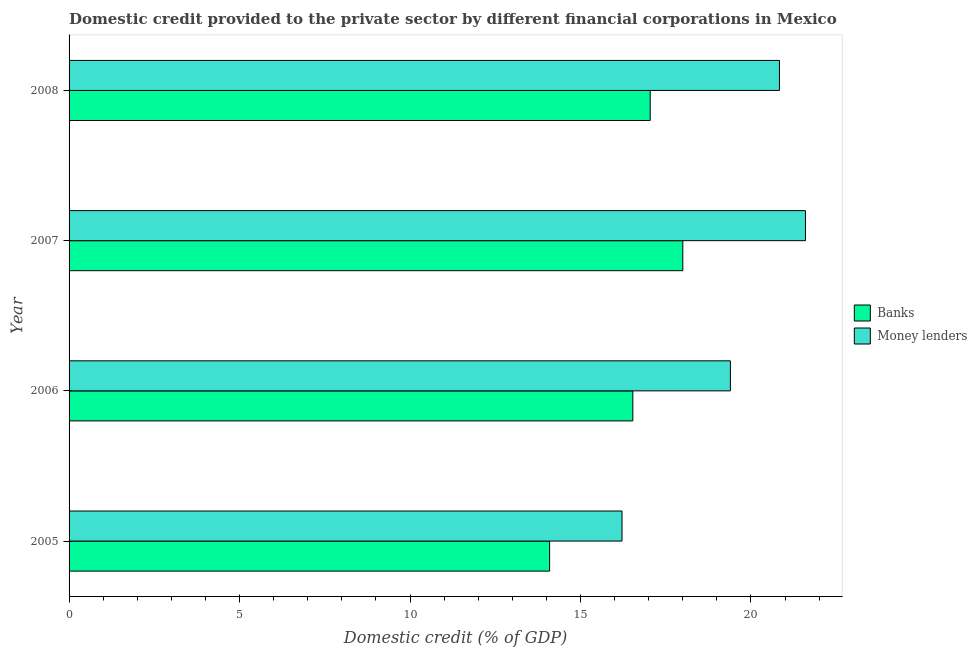How many groups of bars are there?
Your answer should be compact. 4. Are the number of bars on each tick of the Y-axis equal?
Provide a short and direct response. Yes. How many bars are there on the 3rd tick from the top?
Make the answer very short. 2. What is the label of the 3rd group of bars from the top?
Provide a succinct answer. 2006. What is the domestic credit provided by money lenders in 2005?
Keep it short and to the point. 16.22. Across all years, what is the maximum domestic credit provided by banks?
Ensure brevity in your answer.  18. Across all years, what is the minimum domestic credit provided by banks?
Your response must be concise. 14.1. In which year was the domestic credit provided by money lenders maximum?
Provide a short and direct response. 2007. In which year was the domestic credit provided by banks minimum?
Your response must be concise. 2005. What is the total domestic credit provided by money lenders in the graph?
Provide a succinct answer. 78.05. What is the difference between the domestic credit provided by banks in 2005 and that in 2006?
Ensure brevity in your answer.  -2.44. What is the difference between the domestic credit provided by banks in 2007 and the domestic credit provided by money lenders in 2006?
Offer a terse response. -1.4. What is the average domestic credit provided by banks per year?
Keep it short and to the point. 16.42. In the year 2007, what is the difference between the domestic credit provided by banks and domestic credit provided by money lenders?
Your answer should be very brief. -3.6. In how many years, is the domestic credit provided by banks greater than 14 %?
Give a very brief answer. 4. What is the ratio of the domestic credit provided by banks in 2007 to that in 2008?
Your answer should be compact. 1.06. Is the domestic credit provided by money lenders in 2006 less than that in 2007?
Your response must be concise. Yes. What is the difference between the highest and the second highest domestic credit provided by banks?
Offer a terse response. 0.96. What is the difference between the highest and the lowest domestic credit provided by banks?
Provide a succinct answer. 3.91. In how many years, is the domestic credit provided by banks greater than the average domestic credit provided by banks taken over all years?
Your response must be concise. 3. Is the sum of the domestic credit provided by banks in 2005 and 2008 greater than the maximum domestic credit provided by money lenders across all years?
Ensure brevity in your answer.  Yes. What does the 1st bar from the top in 2007 represents?
Provide a short and direct response. Money lenders. What does the 2nd bar from the bottom in 2006 represents?
Your answer should be very brief. Money lenders. How many bars are there?
Your answer should be compact. 8. Are all the bars in the graph horizontal?
Your response must be concise. Yes. What is the difference between two consecutive major ticks on the X-axis?
Keep it short and to the point. 5. Are the values on the major ticks of X-axis written in scientific E-notation?
Ensure brevity in your answer.  No. Does the graph contain any zero values?
Your answer should be compact. No. What is the title of the graph?
Make the answer very short. Domestic credit provided to the private sector by different financial corporations in Mexico. Does "Net savings(excluding particulate emission damage)" appear as one of the legend labels in the graph?
Ensure brevity in your answer.  No. What is the label or title of the X-axis?
Make the answer very short. Domestic credit (% of GDP). What is the label or title of the Y-axis?
Provide a short and direct response. Year. What is the Domestic credit (% of GDP) in Banks in 2005?
Provide a short and direct response. 14.1. What is the Domestic credit (% of GDP) in Money lenders in 2005?
Make the answer very short. 16.22. What is the Domestic credit (% of GDP) of Banks in 2006?
Your response must be concise. 16.54. What is the Domestic credit (% of GDP) in Money lenders in 2006?
Provide a short and direct response. 19.4. What is the Domestic credit (% of GDP) of Banks in 2007?
Make the answer very short. 18. What is the Domestic credit (% of GDP) of Money lenders in 2007?
Keep it short and to the point. 21.6. What is the Domestic credit (% of GDP) of Banks in 2008?
Offer a terse response. 17.05. What is the Domestic credit (% of GDP) of Money lenders in 2008?
Offer a terse response. 20.84. Across all years, what is the maximum Domestic credit (% of GDP) in Banks?
Your answer should be compact. 18. Across all years, what is the maximum Domestic credit (% of GDP) of Money lenders?
Offer a terse response. 21.6. Across all years, what is the minimum Domestic credit (% of GDP) of Banks?
Offer a very short reply. 14.1. Across all years, what is the minimum Domestic credit (% of GDP) in Money lenders?
Keep it short and to the point. 16.22. What is the total Domestic credit (% of GDP) of Banks in the graph?
Your response must be concise. 65.68. What is the total Domestic credit (% of GDP) of Money lenders in the graph?
Offer a terse response. 78.05. What is the difference between the Domestic credit (% of GDP) in Banks in 2005 and that in 2006?
Provide a short and direct response. -2.44. What is the difference between the Domestic credit (% of GDP) in Money lenders in 2005 and that in 2006?
Provide a succinct answer. -3.18. What is the difference between the Domestic credit (% of GDP) of Banks in 2005 and that in 2007?
Your answer should be very brief. -3.91. What is the difference between the Domestic credit (% of GDP) of Money lenders in 2005 and that in 2007?
Offer a very short reply. -5.38. What is the difference between the Domestic credit (% of GDP) of Banks in 2005 and that in 2008?
Your answer should be compact. -2.95. What is the difference between the Domestic credit (% of GDP) in Money lenders in 2005 and that in 2008?
Your response must be concise. -4.62. What is the difference between the Domestic credit (% of GDP) of Banks in 2006 and that in 2007?
Your answer should be compact. -1.47. What is the difference between the Domestic credit (% of GDP) in Money lenders in 2006 and that in 2007?
Offer a very short reply. -2.2. What is the difference between the Domestic credit (% of GDP) of Banks in 2006 and that in 2008?
Ensure brevity in your answer.  -0.51. What is the difference between the Domestic credit (% of GDP) in Money lenders in 2006 and that in 2008?
Your answer should be compact. -1.44. What is the difference between the Domestic credit (% of GDP) of Banks in 2007 and that in 2008?
Keep it short and to the point. 0.96. What is the difference between the Domestic credit (% of GDP) of Money lenders in 2007 and that in 2008?
Give a very brief answer. 0.76. What is the difference between the Domestic credit (% of GDP) in Banks in 2005 and the Domestic credit (% of GDP) in Money lenders in 2006?
Provide a succinct answer. -5.3. What is the difference between the Domestic credit (% of GDP) of Banks in 2005 and the Domestic credit (% of GDP) of Money lenders in 2007?
Offer a terse response. -7.5. What is the difference between the Domestic credit (% of GDP) in Banks in 2005 and the Domestic credit (% of GDP) in Money lenders in 2008?
Provide a succinct answer. -6.74. What is the difference between the Domestic credit (% of GDP) in Banks in 2006 and the Domestic credit (% of GDP) in Money lenders in 2007?
Ensure brevity in your answer.  -5.06. What is the difference between the Domestic credit (% of GDP) of Banks in 2006 and the Domestic credit (% of GDP) of Money lenders in 2008?
Make the answer very short. -4.3. What is the difference between the Domestic credit (% of GDP) of Banks in 2007 and the Domestic credit (% of GDP) of Money lenders in 2008?
Provide a short and direct response. -2.83. What is the average Domestic credit (% of GDP) in Banks per year?
Provide a succinct answer. 16.42. What is the average Domestic credit (% of GDP) of Money lenders per year?
Offer a terse response. 19.51. In the year 2005, what is the difference between the Domestic credit (% of GDP) in Banks and Domestic credit (% of GDP) in Money lenders?
Give a very brief answer. -2.12. In the year 2006, what is the difference between the Domestic credit (% of GDP) of Banks and Domestic credit (% of GDP) of Money lenders?
Your answer should be very brief. -2.86. In the year 2007, what is the difference between the Domestic credit (% of GDP) in Banks and Domestic credit (% of GDP) in Money lenders?
Offer a very short reply. -3.6. In the year 2008, what is the difference between the Domestic credit (% of GDP) of Banks and Domestic credit (% of GDP) of Money lenders?
Give a very brief answer. -3.79. What is the ratio of the Domestic credit (% of GDP) of Banks in 2005 to that in 2006?
Your response must be concise. 0.85. What is the ratio of the Domestic credit (% of GDP) of Money lenders in 2005 to that in 2006?
Give a very brief answer. 0.84. What is the ratio of the Domestic credit (% of GDP) in Banks in 2005 to that in 2007?
Provide a short and direct response. 0.78. What is the ratio of the Domestic credit (% of GDP) in Money lenders in 2005 to that in 2007?
Keep it short and to the point. 0.75. What is the ratio of the Domestic credit (% of GDP) in Banks in 2005 to that in 2008?
Offer a very short reply. 0.83. What is the ratio of the Domestic credit (% of GDP) of Money lenders in 2005 to that in 2008?
Give a very brief answer. 0.78. What is the ratio of the Domestic credit (% of GDP) of Banks in 2006 to that in 2007?
Keep it short and to the point. 0.92. What is the ratio of the Domestic credit (% of GDP) of Money lenders in 2006 to that in 2007?
Make the answer very short. 0.9. What is the ratio of the Domestic credit (% of GDP) in Banks in 2006 to that in 2008?
Offer a very short reply. 0.97. What is the ratio of the Domestic credit (% of GDP) of Money lenders in 2006 to that in 2008?
Offer a very short reply. 0.93. What is the ratio of the Domestic credit (% of GDP) in Banks in 2007 to that in 2008?
Your answer should be very brief. 1.06. What is the ratio of the Domestic credit (% of GDP) of Money lenders in 2007 to that in 2008?
Provide a succinct answer. 1.04. What is the difference between the highest and the second highest Domestic credit (% of GDP) of Banks?
Offer a very short reply. 0.96. What is the difference between the highest and the second highest Domestic credit (% of GDP) of Money lenders?
Keep it short and to the point. 0.76. What is the difference between the highest and the lowest Domestic credit (% of GDP) in Banks?
Give a very brief answer. 3.91. What is the difference between the highest and the lowest Domestic credit (% of GDP) of Money lenders?
Your answer should be very brief. 5.38. 